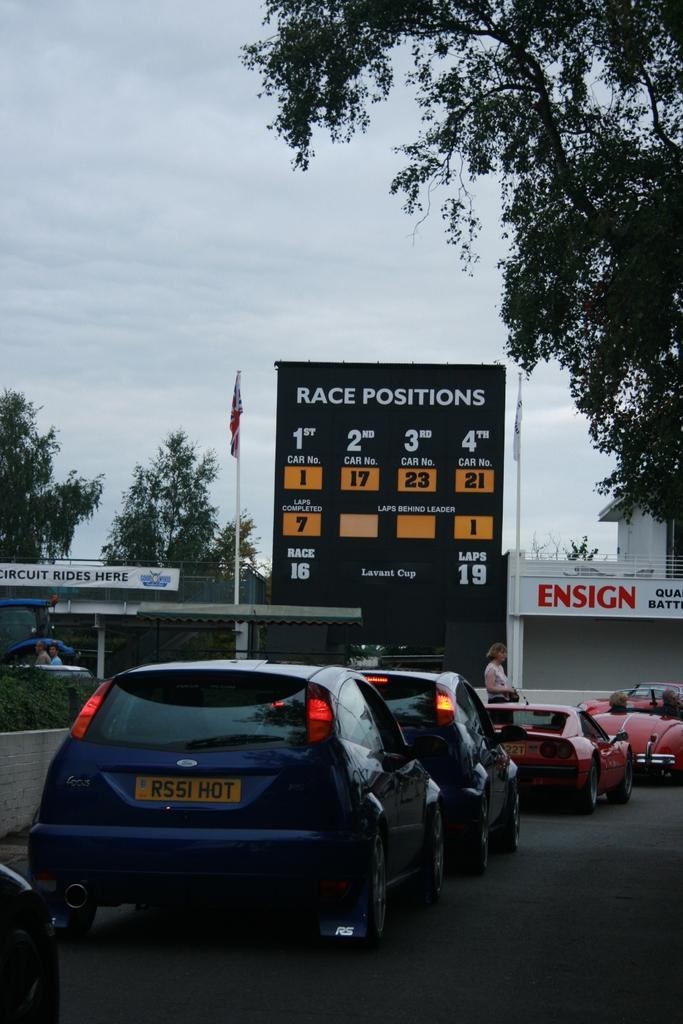What can be seen on the road in the image? There are cars on the road in the image. Who or what else is present in the image? There are people in the image. What can be seen in the background of the image? There is a board, a flag, trees, buildings, and the sky visible in the background of the image. How many sisters are present in the image? There is no mention of sisters in the image, so we cannot determine their presence or number. --- Facts: 1. There is a person holding a book in the image. 2. The person is sitting on a chair. 3. There is a table in the image. 4. The table has a lamp on it. 5. The background of the image is a room. Absurd Topics: elephant, ocean, parachute Conversation: What is the person in the image holding? The person in the image is holding a book. Where is the person sitting in the image? The person is sitting on a chair. What can be seen on the table in the image? The table has a lamp on it. What is the setting of the image? The background of the image is a room. Reasoning: Let's think step by step in order to produce the conversation. We start by identifying the main subject in the image, which is the person holding a book. Then, we expand the conversation to include other subjects and objects that are also visible, such as the chair, the table, and the lamp. Each question is designed to elicit a specific detail about the image that is known from the provided facts. Absurd Question/Answer: Can you see an elephant swimming in the ocean in the image? No, there is no elephant or ocean present in the image. 